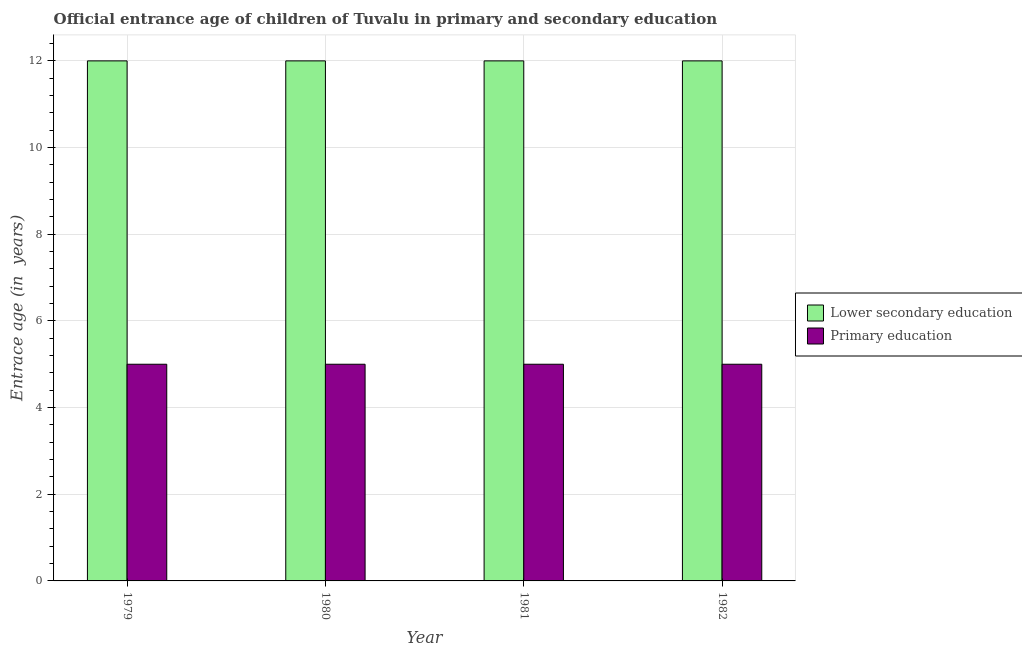Are the number of bars per tick equal to the number of legend labels?
Your answer should be compact. Yes. Are the number of bars on each tick of the X-axis equal?
Keep it short and to the point. Yes. How many bars are there on the 2nd tick from the right?
Provide a succinct answer. 2. What is the label of the 4th group of bars from the left?
Make the answer very short. 1982. In how many cases, is the number of bars for a given year not equal to the number of legend labels?
Keep it short and to the point. 0. What is the entrance age of children in lower secondary education in 1980?
Ensure brevity in your answer.  12. Across all years, what is the maximum entrance age of chiildren in primary education?
Your response must be concise. 5. Across all years, what is the minimum entrance age of children in lower secondary education?
Keep it short and to the point. 12. In which year was the entrance age of children in lower secondary education maximum?
Offer a very short reply. 1979. In which year was the entrance age of children in lower secondary education minimum?
Your answer should be very brief. 1979. What is the total entrance age of chiildren in primary education in the graph?
Provide a short and direct response. 20. What is the difference between the entrance age of children in lower secondary education in 1979 and that in 1981?
Provide a succinct answer. 0. What is the average entrance age of children in lower secondary education per year?
Your answer should be very brief. 12. In the year 1980, what is the difference between the entrance age of children in lower secondary education and entrance age of chiildren in primary education?
Give a very brief answer. 0. In how many years, is the entrance age of chiildren in primary education greater than 1.6 years?
Give a very brief answer. 4. Is the entrance age of children in lower secondary education in 1981 less than that in 1982?
Your answer should be very brief. No. What is the difference between the highest and the lowest entrance age of children in lower secondary education?
Your response must be concise. 0. Is the sum of the entrance age of chiildren in primary education in 1980 and 1982 greater than the maximum entrance age of children in lower secondary education across all years?
Your answer should be very brief. Yes. What does the 1st bar from the left in 1982 represents?
Your response must be concise. Lower secondary education. What does the 2nd bar from the right in 1982 represents?
Provide a succinct answer. Lower secondary education. How many bars are there?
Make the answer very short. 8. Are all the bars in the graph horizontal?
Your answer should be compact. No. Where does the legend appear in the graph?
Ensure brevity in your answer.  Center right. How many legend labels are there?
Provide a short and direct response. 2. How are the legend labels stacked?
Provide a succinct answer. Vertical. What is the title of the graph?
Provide a short and direct response. Official entrance age of children of Tuvalu in primary and secondary education. Does "Female labourers" appear as one of the legend labels in the graph?
Your answer should be very brief. No. What is the label or title of the X-axis?
Offer a very short reply. Year. What is the label or title of the Y-axis?
Your response must be concise. Entrace age (in  years). What is the Entrace age (in  years) in Lower secondary education in 1980?
Your response must be concise. 12. What is the Entrace age (in  years) in Primary education in 1980?
Offer a terse response. 5. What is the Entrace age (in  years) of Lower secondary education in 1982?
Provide a succinct answer. 12. Across all years, what is the maximum Entrace age (in  years) of Primary education?
Your answer should be very brief. 5. Across all years, what is the minimum Entrace age (in  years) in Lower secondary education?
Provide a succinct answer. 12. What is the difference between the Entrace age (in  years) in Primary education in 1979 and that in 1980?
Ensure brevity in your answer.  0. What is the difference between the Entrace age (in  years) in Lower secondary education in 1979 and that in 1981?
Give a very brief answer. 0. What is the difference between the Entrace age (in  years) of Lower secondary education in 1979 and that in 1982?
Provide a succinct answer. 0. What is the difference between the Entrace age (in  years) of Primary education in 1979 and that in 1982?
Offer a terse response. 0. What is the difference between the Entrace age (in  years) of Lower secondary education in 1980 and that in 1982?
Keep it short and to the point. 0. What is the difference between the Entrace age (in  years) of Lower secondary education in 1981 and that in 1982?
Give a very brief answer. 0. What is the difference between the Entrace age (in  years) of Primary education in 1981 and that in 1982?
Provide a short and direct response. 0. What is the difference between the Entrace age (in  years) of Lower secondary education in 1979 and the Entrace age (in  years) of Primary education in 1980?
Provide a short and direct response. 7. What is the difference between the Entrace age (in  years) in Lower secondary education in 1980 and the Entrace age (in  years) in Primary education in 1982?
Offer a terse response. 7. What is the difference between the Entrace age (in  years) of Lower secondary education in 1981 and the Entrace age (in  years) of Primary education in 1982?
Your answer should be compact. 7. What is the average Entrace age (in  years) of Lower secondary education per year?
Provide a short and direct response. 12. In the year 1979, what is the difference between the Entrace age (in  years) in Lower secondary education and Entrace age (in  years) in Primary education?
Your answer should be compact. 7. In the year 1980, what is the difference between the Entrace age (in  years) in Lower secondary education and Entrace age (in  years) in Primary education?
Provide a succinct answer. 7. What is the ratio of the Entrace age (in  years) of Lower secondary education in 1979 to that in 1980?
Provide a short and direct response. 1. What is the ratio of the Entrace age (in  years) in Lower secondary education in 1979 to that in 1981?
Your answer should be compact. 1. What is the ratio of the Entrace age (in  years) of Primary education in 1979 to that in 1981?
Ensure brevity in your answer.  1. What is the ratio of the Entrace age (in  years) of Lower secondary education in 1979 to that in 1982?
Make the answer very short. 1. What is the ratio of the Entrace age (in  years) in Lower secondary education in 1980 to that in 1981?
Provide a succinct answer. 1. What is the ratio of the Entrace age (in  years) in Lower secondary education in 1980 to that in 1982?
Your response must be concise. 1. What is the ratio of the Entrace age (in  years) in Primary education in 1980 to that in 1982?
Offer a very short reply. 1. What is the difference between the highest and the second highest Entrace age (in  years) of Lower secondary education?
Make the answer very short. 0. What is the difference between the highest and the lowest Entrace age (in  years) in Lower secondary education?
Your answer should be compact. 0. 